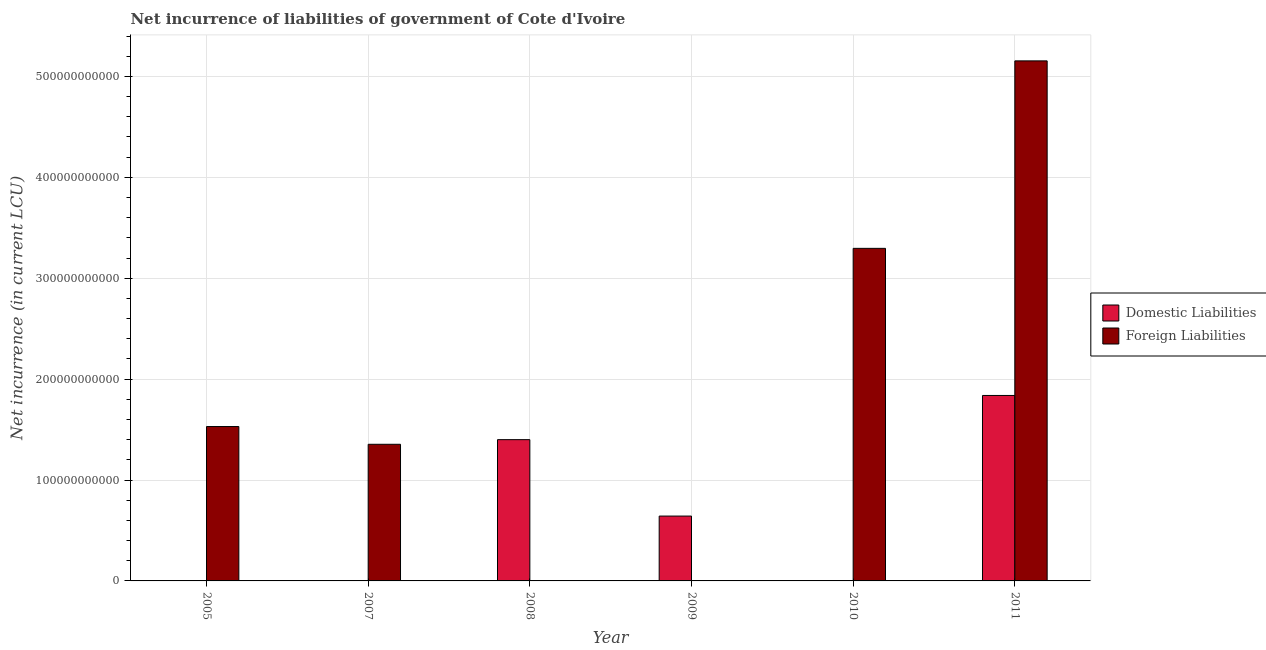Are the number of bars per tick equal to the number of legend labels?
Your answer should be very brief. No. Are the number of bars on each tick of the X-axis equal?
Make the answer very short. No. How many bars are there on the 6th tick from the right?
Provide a succinct answer. 1. What is the label of the 5th group of bars from the left?
Offer a very short reply. 2010. In how many cases, is the number of bars for a given year not equal to the number of legend labels?
Offer a very short reply. 5. Across all years, what is the maximum net incurrence of foreign liabilities?
Make the answer very short. 5.15e+11. In which year was the net incurrence of domestic liabilities maximum?
Ensure brevity in your answer.  2011. What is the total net incurrence of domestic liabilities in the graph?
Your answer should be compact. 3.88e+11. What is the difference between the net incurrence of foreign liabilities in 2005 and that in 2007?
Give a very brief answer. 1.76e+1. What is the difference between the net incurrence of foreign liabilities in 2011 and the net incurrence of domestic liabilities in 2009?
Provide a short and direct response. 5.15e+11. What is the average net incurrence of domestic liabilities per year?
Provide a short and direct response. 6.47e+1. What is the ratio of the net incurrence of foreign liabilities in 2005 to that in 2010?
Your answer should be very brief. 0.46. Is the net incurrence of foreign liabilities in 2005 less than that in 2011?
Offer a very short reply. Yes. What is the difference between the highest and the second highest net incurrence of foreign liabilities?
Provide a succinct answer. 1.86e+11. What is the difference between the highest and the lowest net incurrence of domestic liabilities?
Your response must be concise. 1.84e+11. Are all the bars in the graph horizontal?
Keep it short and to the point. No. How many years are there in the graph?
Provide a short and direct response. 6. What is the difference between two consecutive major ticks on the Y-axis?
Offer a very short reply. 1.00e+11. Where does the legend appear in the graph?
Give a very brief answer. Center right. How many legend labels are there?
Your response must be concise. 2. How are the legend labels stacked?
Give a very brief answer. Vertical. What is the title of the graph?
Your response must be concise. Net incurrence of liabilities of government of Cote d'Ivoire. Does "Rural Population" appear as one of the legend labels in the graph?
Keep it short and to the point. No. What is the label or title of the X-axis?
Your answer should be very brief. Year. What is the label or title of the Y-axis?
Your answer should be very brief. Net incurrence (in current LCU). What is the Net incurrence (in current LCU) of Domestic Liabilities in 2005?
Your response must be concise. 0. What is the Net incurrence (in current LCU) in Foreign Liabilities in 2005?
Ensure brevity in your answer.  1.53e+11. What is the Net incurrence (in current LCU) in Domestic Liabilities in 2007?
Your answer should be very brief. 0. What is the Net incurrence (in current LCU) in Foreign Liabilities in 2007?
Make the answer very short. 1.35e+11. What is the Net incurrence (in current LCU) in Domestic Liabilities in 2008?
Make the answer very short. 1.40e+11. What is the Net incurrence (in current LCU) of Foreign Liabilities in 2008?
Your response must be concise. 0. What is the Net incurrence (in current LCU) in Domestic Liabilities in 2009?
Ensure brevity in your answer.  6.43e+1. What is the Net incurrence (in current LCU) of Foreign Liabilities in 2009?
Ensure brevity in your answer.  0. What is the Net incurrence (in current LCU) in Foreign Liabilities in 2010?
Your response must be concise. 3.30e+11. What is the Net incurrence (in current LCU) in Domestic Liabilities in 2011?
Keep it short and to the point. 1.84e+11. What is the Net incurrence (in current LCU) of Foreign Liabilities in 2011?
Provide a succinct answer. 5.15e+11. Across all years, what is the maximum Net incurrence (in current LCU) in Domestic Liabilities?
Your answer should be compact. 1.84e+11. Across all years, what is the maximum Net incurrence (in current LCU) of Foreign Liabilities?
Provide a succinct answer. 5.15e+11. Across all years, what is the minimum Net incurrence (in current LCU) in Domestic Liabilities?
Keep it short and to the point. 0. What is the total Net incurrence (in current LCU) in Domestic Liabilities in the graph?
Keep it short and to the point. 3.88e+11. What is the total Net incurrence (in current LCU) of Foreign Liabilities in the graph?
Provide a succinct answer. 1.13e+12. What is the difference between the Net incurrence (in current LCU) in Foreign Liabilities in 2005 and that in 2007?
Make the answer very short. 1.76e+1. What is the difference between the Net incurrence (in current LCU) of Foreign Liabilities in 2005 and that in 2010?
Your answer should be very brief. -1.77e+11. What is the difference between the Net incurrence (in current LCU) of Foreign Liabilities in 2005 and that in 2011?
Ensure brevity in your answer.  -3.62e+11. What is the difference between the Net incurrence (in current LCU) in Foreign Liabilities in 2007 and that in 2010?
Provide a short and direct response. -1.94e+11. What is the difference between the Net incurrence (in current LCU) in Foreign Liabilities in 2007 and that in 2011?
Give a very brief answer. -3.80e+11. What is the difference between the Net incurrence (in current LCU) of Domestic Liabilities in 2008 and that in 2009?
Your answer should be compact. 7.57e+1. What is the difference between the Net incurrence (in current LCU) in Domestic Liabilities in 2008 and that in 2011?
Offer a terse response. -4.38e+1. What is the difference between the Net incurrence (in current LCU) in Domestic Liabilities in 2009 and that in 2011?
Your answer should be very brief. -1.20e+11. What is the difference between the Net incurrence (in current LCU) of Foreign Liabilities in 2010 and that in 2011?
Ensure brevity in your answer.  -1.86e+11. What is the difference between the Net incurrence (in current LCU) in Domestic Liabilities in 2008 and the Net incurrence (in current LCU) in Foreign Liabilities in 2010?
Keep it short and to the point. -1.90e+11. What is the difference between the Net incurrence (in current LCU) in Domestic Liabilities in 2008 and the Net incurrence (in current LCU) in Foreign Liabilities in 2011?
Your response must be concise. -3.75e+11. What is the difference between the Net incurrence (in current LCU) in Domestic Liabilities in 2009 and the Net incurrence (in current LCU) in Foreign Liabilities in 2010?
Offer a terse response. -2.65e+11. What is the difference between the Net incurrence (in current LCU) in Domestic Liabilities in 2009 and the Net incurrence (in current LCU) in Foreign Liabilities in 2011?
Offer a very short reply. -4.51e+11. What is the average Net incurrence (in current LCU) of Domestic Liabilities per year?
Offer a terse response. 6.47e+1. What is the average Net incurrence (in current LCU) of Foreign Liabilities per year?
Give a very brief answer. 1.89e+11. In the year 2011, what is the difference between the Net incurrence (in current LCU) in Domestic Liabilities and Net incurrence (in current LCU) in Foreign Liabilities?
Your answer should be very brief. -3.32e+11. What is the ratio of the Net incurrence (in current LCU) in Foreign Liabilities in 2005 to that in 2007?
Make the answer very short. 1.13. What is the ratio of the Net incurrence (in current LCU) in Foreign Liabilities in 2005 to that in 2010?
Make the answer very short. 0.46. What is the ratio of the Net incurrence (in current LCU) of Foreign Liabilities in 2005 to that in 2011?
Make the answer very short. 0.3. What is the ratio of the Net incurrence (in current LCU) in Foreign Liabilities in 2007 to that in 2010?
Provide a short and direct response. 0.41. What is the ratio of the Net incurrence (in current LCU) of Foreign Liabilities in 2007 to that in 2011?
Provide a succinct answer. 0.26. What is the ratio of the Net incurrence (in current LCU) in Domestic Liabilities in 2008 to that in 2009?
Offer a terse response. 2.18. What is the ratio of the Net incurrence (in current LCU) of Domestic Liabilities in 2008 to that in 2011?
Offer a terse response. 0.76. What is the ratio of the Net incurrence (in current LCU) in Domestic Liabilities in 2009 to that in 2011?
Keep it short and to the point. 0.35. What is the ratio of the Net incurrence (in current LCU) in Foreign Liabilities in 2010 to that in 2011?
Give a very brief answer. 0.64. What is the difference between the highest and the second highest Net incurrence (in current LCU) of Domestic Liabilities?
Your response must be concise. 4.38e+1. What is the difference between the highest and the second highest Net incurrence (in current LCU) in Foreign Liabilities?
Keep it short and to the point. 1.86e+11. What is the difference between the highest and the lowest Net incurrence (in current LCU) in Domestic Liabilities?
Make the answer very short. 1.84e+11. What is the difference between the highest and the lowest Net incurrence (in current LCU) of Foreign Liabilities?
Give a very brief answer. 5.15e+11. 